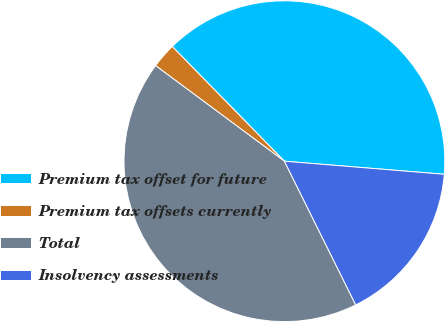Convert chart to OTSL. <chart><loc_0><loc_0><loc_500><loc_500><pie_chart><fcel>Premium tax offset for future<fcel>Premium tax offsets currently<fcel>Total<fcel>Insolvency assessments<nl><fcel>38.62%<fcel>2.52%<fcel>42.49%<fcel>16.37%<nl></chart> 